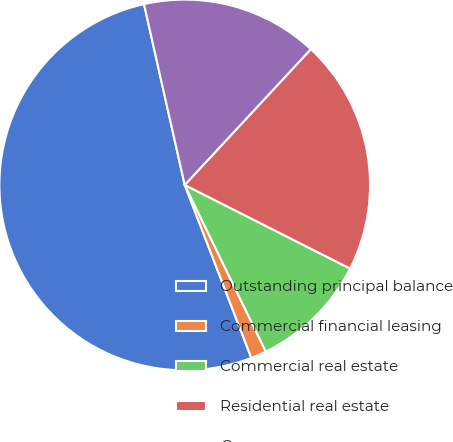Convert chart to OTSL. <chart><loc_0><loc_0><loc_500><loc_500><pie_chart><fcel>Outstanding principal balance<fcel>Commercial financial leasing<fcel>Commercial real estate<fcel>Residential real estate<fcel>Consumer<nl><fcel>52.33%<fcel>1.36%<fcel>10.34%<fcel>20.54%<fcel>15.44%<nl></chart> 